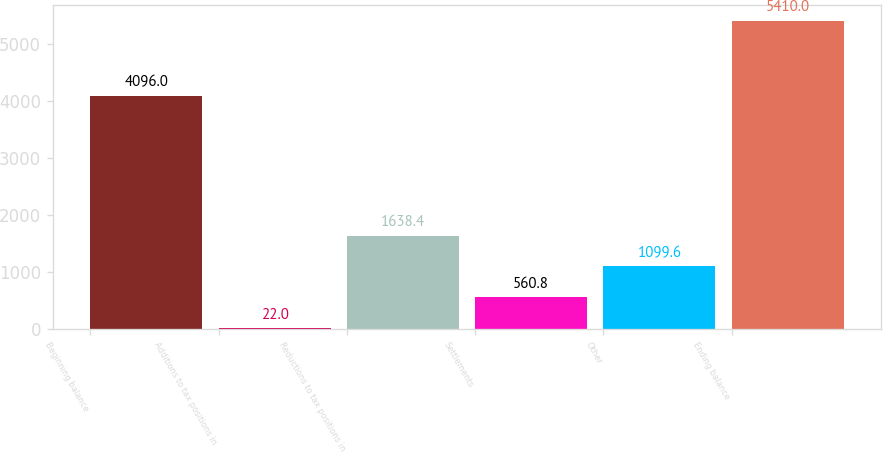<chart> <loc_0><loc_0><loc_500><loc_500><bar_chart><fcel>Beginning balance<fcel>Additions to tax positions in<fcel>Reductions to tax positions in<fcel>Settlements<fcel>Other<fcel>Ending balance<nl><fcel>4096<fcel>22<fcel>1638.4<fcel>560.8<fcel>1099.6<fcel>5410<nl></chart> 